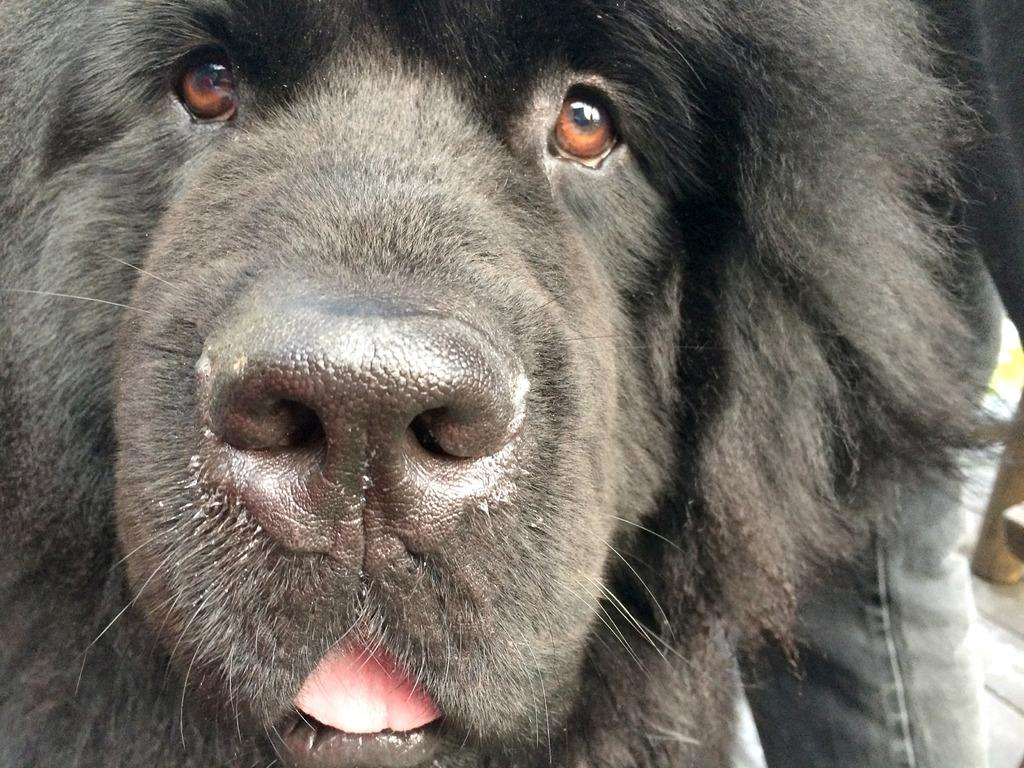What type of animal is in the picture? There is a black color dog in the picture. Can you describe any part of a person in the image? A person's leg is visible in the picture. What type of clothing is the person wearing? The person is wearing jeans pants. What type of treatment is the dog receiving in the picture? There is no indication in the image that the dog is receiving any treatment. 